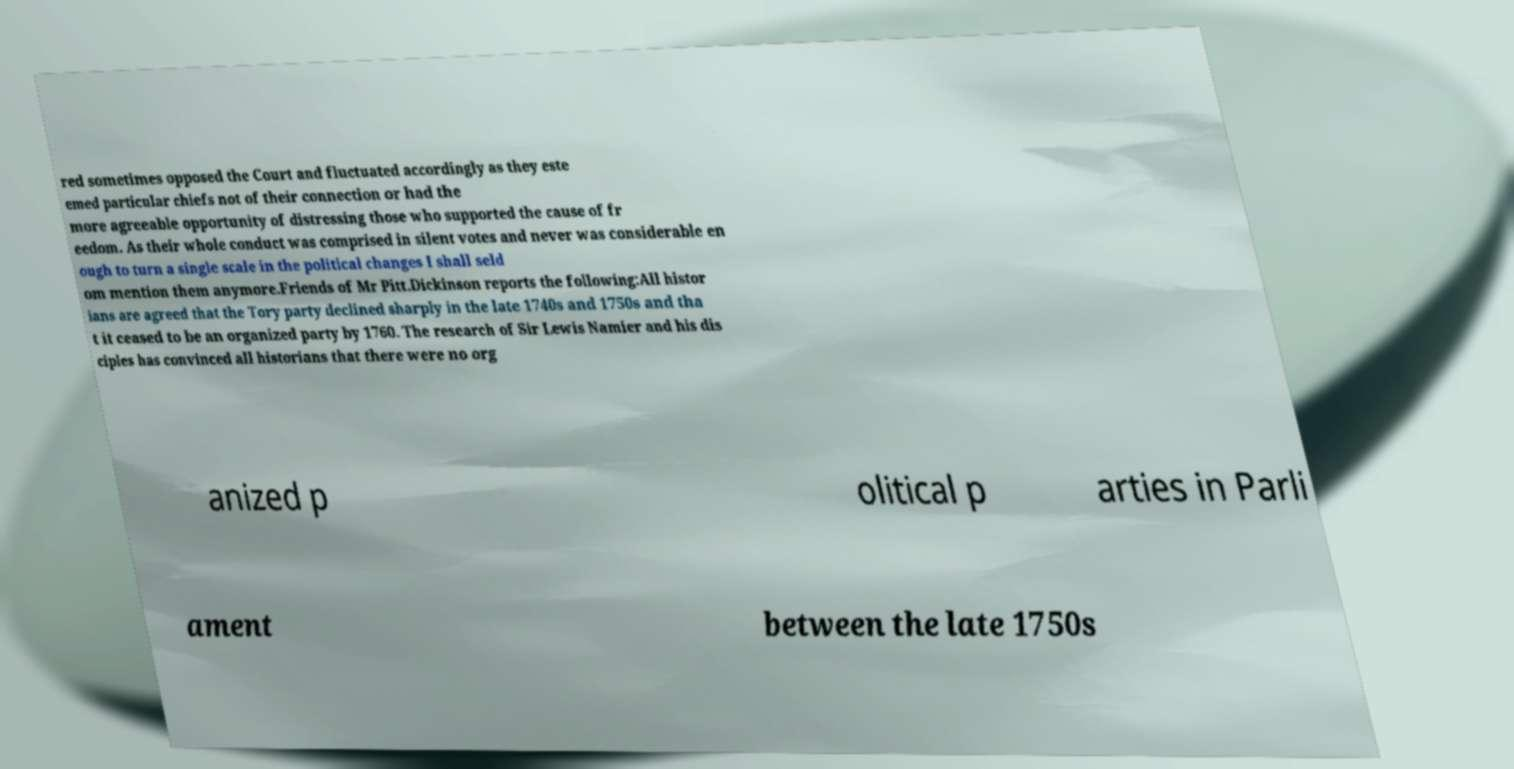Please read and relay the text visible in this image. What does it say? red sometimes opposed the Court and fluctuated accordingly as they este emed particular chiefs not of their connection or had the more agreeable opportunity of distressing those who supported the cause of fr eedom. As their whole conduct was comprised in silent votes and never was considerable en ough to turn a single scale in the political changes I shall seld om mention them anymore.Friends of Mr Pitt.Dickinson reports the following:All histor ians are agreed that the Tory party declined sharply in the late 1740s and 1750s and tha t it ceased to be an organized party by 1760. The research of Sir Lewis Namier and his dis ciples has convinced all historians that there were no org anized p olitical p arties in Parli ament between the late 1750s 